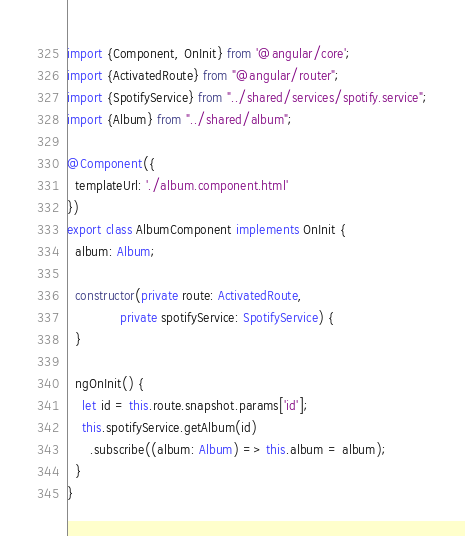Convert code to text. <code><loc_0><loc_0><loc_500><loc_500><_TypeScript_>import {Component, OnInit} from '@angular/core';
import {ActivatedRoute} from "@angular/router";
import {SpotifyService} from "../shared/services/spotify.service";
import {Album} from "../shared/album";

@Component({
  templateUrl: './album.component.html'
})
export class AlbumComponent implements OnInit {
  album: Album;

  constructor(private route: ActivatedRoute,
              private spotifyService: SpotifyService) {
  }

  ngOnInit() {
    let id = this.route.snapshot.params['id'];
    this.spotifyService.getAlbum(id)
      .subscribe((album: Album) => this.album = album);
  }
}
</code> 